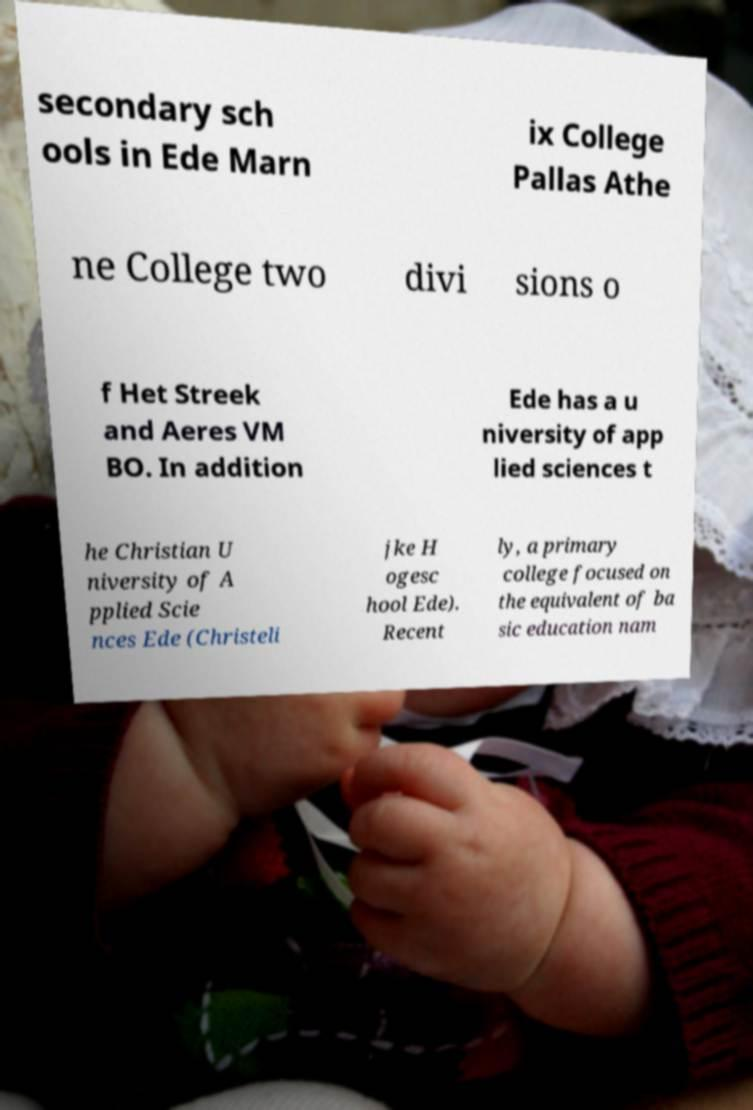I need the written content from this picture converted into text. Can you do that? secondary sch ools in Ede Marn ix College Pallas Athe ne College two divi sions o f Het Streek and Aeres VM BO. In addition Ede has a u niversity of app lied sciences t he Christian U niversity of A pplied Scie nces Ede (Christeli jke H ogesc hool Ede). Recent ly, a primary college focused on the equivalent of ba sic education nam 